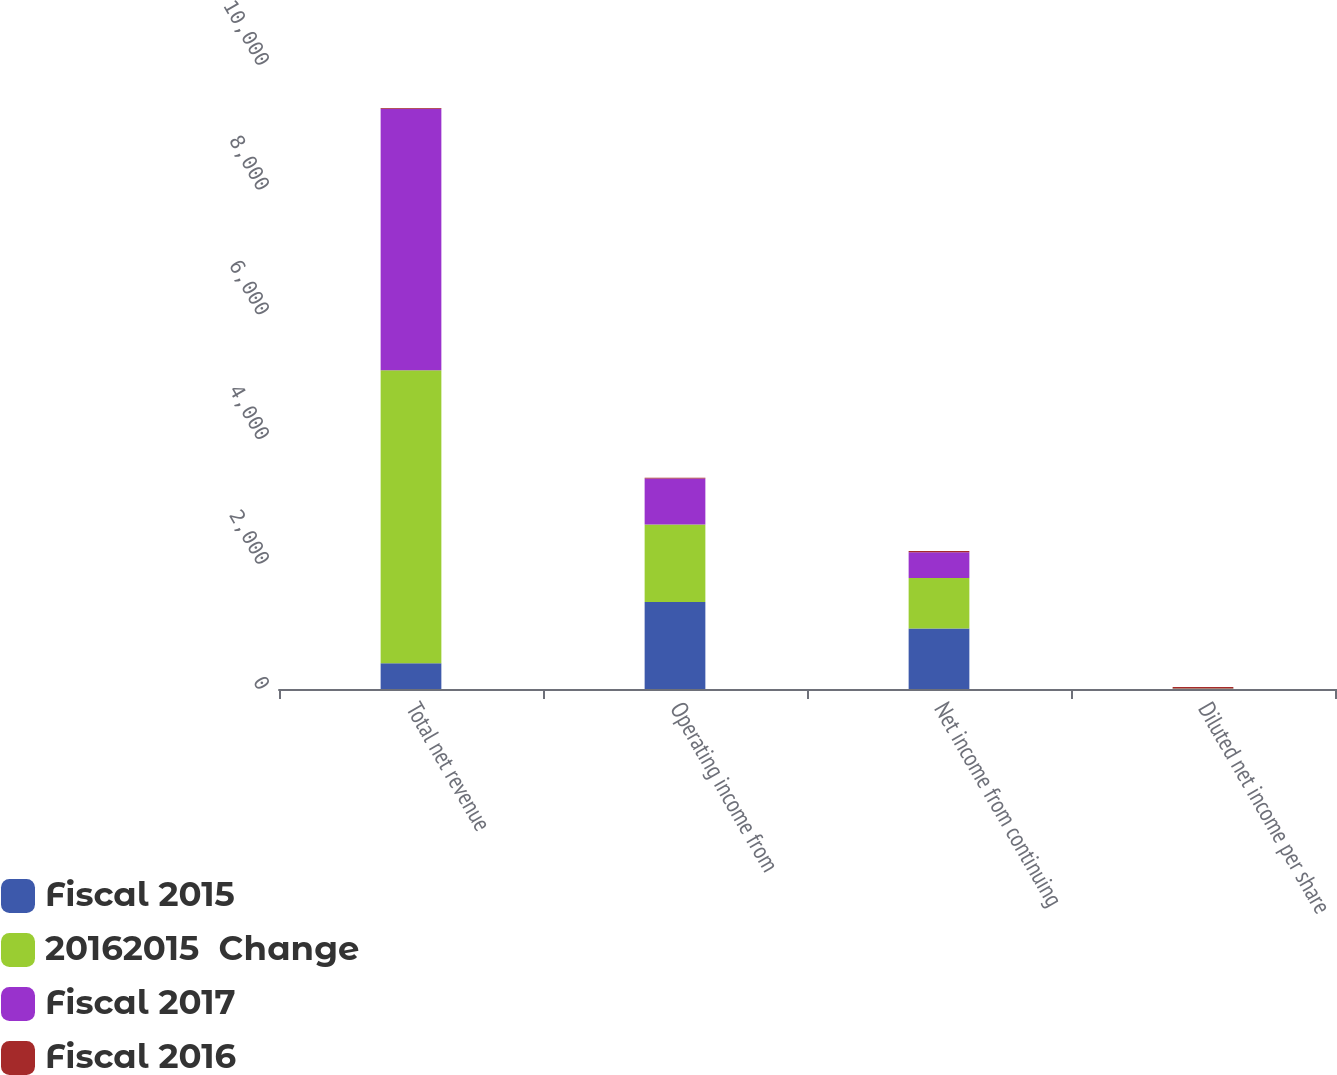Convert chart to OTSL. <chart><loc_0><loc_0><loc_500><loc_500><stacked_bar_chart><ecel><fcel>Total net revenue<fcel>Operating income from<fcel>Net income from continuing<fcel>Diluted net income per share<nl><fcel>Fiscal 2015<fcel>413<fcel>1395<fcel>971<fcel>3.72<nl><fcel>20162015  Change<fcel>4694<fcel>1242<fcel>806<fcel>3.04<nl><fcel>Fiscal 2017<fcel>4192<fcel>738<fcel>413<fcel>1.45<nl><fcel>Fiscal 2016<fcel>10<fcel>12<fcel>20<fcel>22<nl></chart> 